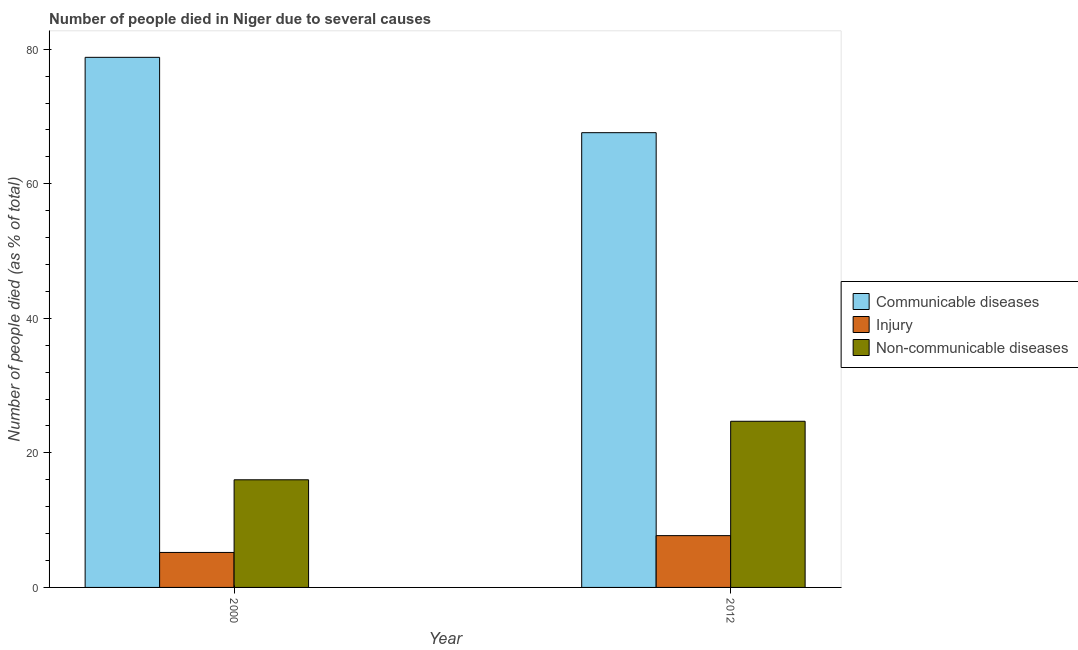How many different coloured bars are there?
Make the answer very short. 3. How many groups of bars are there?
Provide a short and direct response. 2. How many bars are there on the 2nd tick from the left?
Ensure brevity in your answer.  3. How many bars are there on the 2nd tick from the right?
Provide a short and direct response. 3. Across all years, what is the maximum number of people who died of communicable diseases?
Give a very brief answer. 78.8. In which year was the number of people who died of injury maximum?
Offer a terse response. 2012. What is the total number of people who died of communicable diseases in the graph?
Give a very brief answer. 146.4. What is the difference between the number of people who died of communicable diseases in 2000 and the number of people who dies of non-communicable diseases in 2012?
Keep it short and to the point. 11.2. What is the average number of people who died of injury per year?
Ensure brevity in your answer.  6.45. In the year 2000, what is the difference between the number of people who died of injury and number of people who dies of non-communicable diseases?
Provide a short and direct response. 0. In how many years, is the number of people who dies of non-communicable diseases greater than 48 %?
Provide a succinct answer. 0. What is the ratio of the number of people who died of injury in 2000 to that in 2012?
Your answer should be compact. 0.68. Is the number of people who dies of non-communicable diseases in 2000 less than that in 2012?
Provide a succinct answer. Yes. In how many years, is the number of people who died of injury greater than the average number of people who died of injury taken over all years?
Provide a succinct answer. 1. What does the 1st bar from the left in 2000 represents?
Your response must be concise. Communicable diseases. What does the 3rd bar from the right in 2012 represents?
Offer a terse response. Communicable diseases. Does the graph contain any zero values?
Make the answer very short. No. Does the graph contain grids?
Provide a short and direct response. No. How are the legend labels stacked?
Provide a succinct answer. Vertical. What is the title of the graph?
Keep it short and to the point. Number of people died in Niger due to several causes. Does "Transport services" appear as one of the legend labels in the graph?
Your response must be concise. No. What is the label or title of the Y-axis?
Provide a succinct answer. Number of people died (as % of total). What is the Number of people died (as % of total) of Communicable diseases in 2000?
Ensure brevity in your answer.  78.8. What is the Number of people died (as % of total) of Communicable diseases in 2012?
Make the answer very short. 67.6. What is the Number of people died (as % of total) of Non-communicable diseases in 2012?
Offer a terse response. 24.7. Across all years, what is the maximum Number of people died (as % of total) in Communicable diseases?
Your answer should be compact. 78.8. Across all years, what is the maximum Number of people died (as % of total) of Non-communicable diseases?
Provide a short and direct response. 24.7. Across all years, what is the minimum Number of people died (as % of total) in Communicable diseases?
Offer a very short reply. 67.6. Across all years, what is the minimum Number of people died (as % of total) of Non-communicable diseases?
Offer a terse response. 16. What is the total Number of people died (as % of total) of Communicable diseases in the graph?
Keep it short and to the point. 146.4. What is the total Number of people died (as % of total) of Non-communicable diseases in the graph?
Provide a succinct answer. 40.7. What is the difference between the Number of people died (as % of total) in Injury in 2000 and that in 2012?
Give a very brief answer. -2.5. What is the difference between the Number of people died (as % of total) of Non-communicable diseases in 2000 and that in 2012?
Your answer should be very brief. -8.7. What is the difference between the Number of people died (as % of total) of Communicable diseases in 2000 and the Number of people died (as % of total) of Injury in 2012?
Your answer should be very brief. 71.1. What is the difference between the Number of people died (as % of total) of Communicable diseases in 2000 and the Number of people died (as % of total) of Non-communicable diseases in 2012?
Offer a very short reply. 54.1. What is the difference between the Number of people died (as % of total) of Injury in 2000 and the Number of people died (as % of total) of Non-communicable diseases in 2012?
Provide a succinct answer. -19.5. What is the average Number of people died (as % of total) of Communicable diseases per year?
Keep it short and to the point. 73.2. What is the average Number of people died (as % of total) in Injury per year?
Give a very brief answer. 6.45. What is the average Number of people died (as % of total) in Non-communicable diseases per year?
Your answer should be compact. 20.35. In the year 2000, what is the difference between the Number of people died (as % of total) in Communicable diseases and Number of people died (as % of total) in Injury?
Offer a very short reply. 73.6. In the year 2000, what is the difference between the Number of people died (as % of total) of Communicable diseases and Number of people died (as % of total) of Non-communicable diseases?
Your answer should be compact. 62.8. In the year 2000, what is the difference between the Number of people died (as % of total) in Injury and Number of people died (as % of total) in Non-communicable diseases?
Provide a short and direct response. -10.8. In the year 2012, what is the difference between the Number of people died (as % of total) in Communicable diseases and Number of people died (as % of total) in Injury?
Your response must be concise. 59.9. In the year 2012, what is the difference between the Number of people died (as % of total) of Communicable diseases and Number of people died (as % of total) of Non-communicable diseases?
Offer a very short reply. 42.9. What is the ratio of the Number of people died (as % of total) in Communicable diseases in 2000 to that in 2012?
Offer a very short reply. 1.17. What is the ratio of the Number of people died (as % of total) in Injury in 2000 to that in 2012?
Offer a terse response. 0.68. What is the ratio of the Number of people died (as % of total) in Non-communicable diseases in 2000 to that in 2012?
Your answer should be compact. 0.65. What is the difference between the highest and the second highest Number of people died (as % of total) in Injury?
Your answer should be very brief. 2.5. What is the difference between the highest and the second highest Number of people died (as % of total) of Non-communicable diseases?
Provide a succinct answer. 8.7. What is the difference between the highest and the lowest Number of people died (as % of total) of Communicable diseases?
Ensure brevity in your answer.  11.2. What is the difference between the highest and the lowest Number of people died (as % of total) in Non-communicable diseases?
Offer a very short reply. 8.7. 